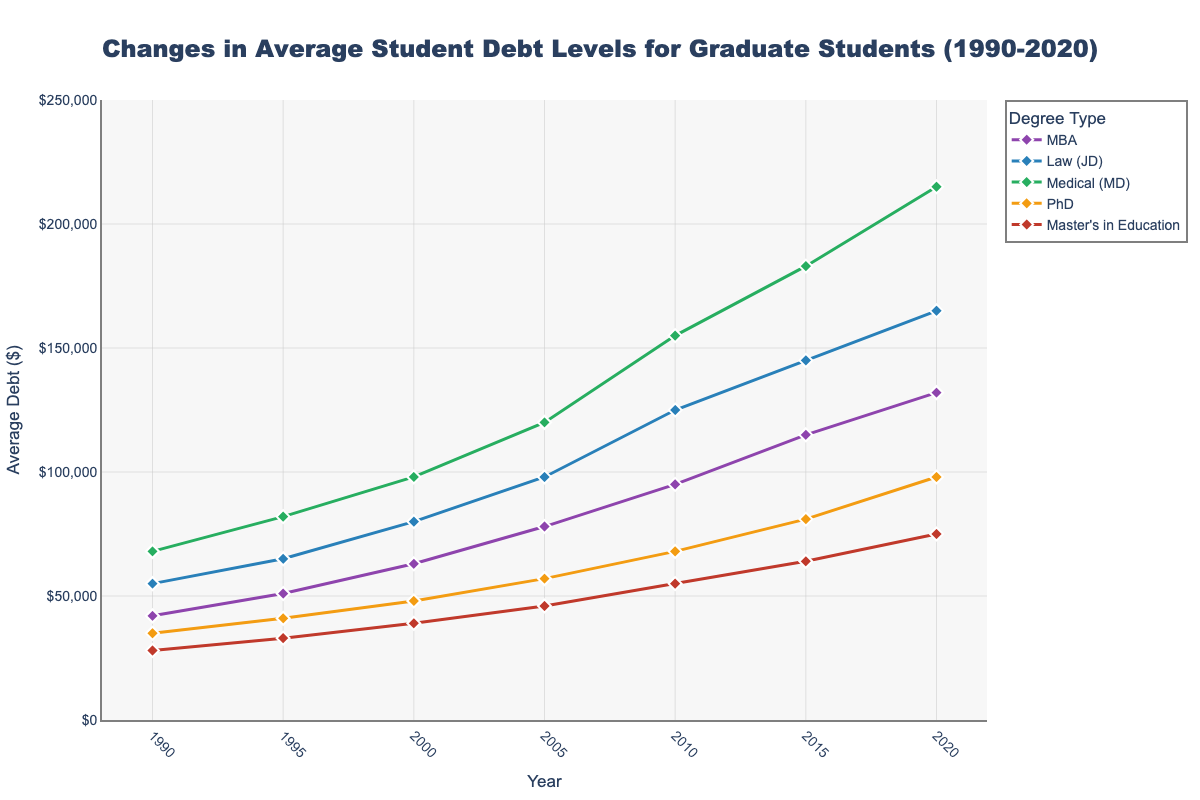What's the average student debt for an MBA student in 2020? The figure shows the student debt levels for different degree types over the years. For an MBA student in 2020, the debt level is shown right next to 2020 on the x-axis under the line corresponding to the MBA.
Answer: $132,000 Which degree type experienced the highest increase in student debt from 1990 to 2020? To find the degree type with the highest increase, subtract the 1990 value from the 2020 value for each degree type, then compare the results. MBA: (132,000 - 42,000) = 90,000; JD: (165,000 - 55,000) = 110,000; MD: (215,000 - 68,000) = 147,000; PhD: (98,000 - 35,000) = 63,000; Master's in Education: (75,000 - 28,000) = 47,000. The MD degree experienced the highest increase.
Answer: Medical (MD) Between 2010 and 2020, which degree type had the smallest increase in student debt? Subtract the 2010 value from the 2020 value for each degree type and compare the results. MBA: (132,000 - 95,000) = 37,000; JD: (165,000 - 125,000) = 40,000; MD: (215,000 - 155,000) = 60,000; PhD: (98,000 - 68,000) = 30,000; Master's in Education: (75,000 - 55,000) = 20,000. The smallest increase is for Master's in Education.
Answer: Master's in Education What was the trend in student debt for PhD students from 1990 to 2020? Looking at the figure, observe the change in the line corresponding to PhD from 1990 to 2020. The line shows a generally increasing trend over these years.
Answer: Increasing Which degree type had the lowest average debt in 2010? Check the data points for all degree types at the year 2010 and compare them. MBA: 95,000; JD: 125,000; MD: 155,000; PhD: 68,000; Master's in Education: 55,000. The lowest average debt is for Master's in Education at $55,000.
Answer: Master's in Education How did the average debt for MBA students change from 1995 to 2005? Subtract the 1995 value from the 2005 value for MBA: (78,000 - 51,000) = 27,000. So, the increase is $27,000.
Answer: $27,000 Compare the average student debt between an MBA and PhD in 2020. Which one is higher? Look at the 2020 data points for both MBA and PhD: MBA is $132,000, and PhD is $98,000. MBA is higher than PhD.
Answer: MBA What is the total increase in debt for Law students (JD) from 1990 to 2020? Subtract the 1990 value from the 2020 value for Law (JD): (165,000 - 55,000) = 110,000.
Answer: $110,000 